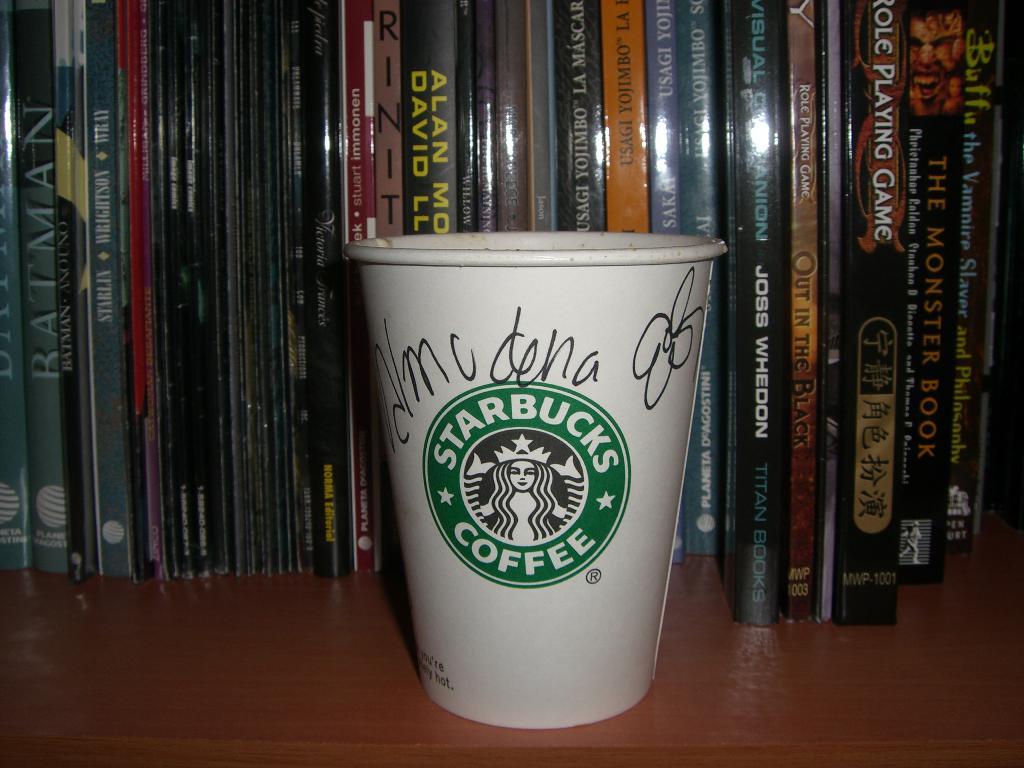Where did this person go to get this drink?
Provide a succinct answer. Starbucks. What is the drink?
Provide a succinct answer. Starbucks. 